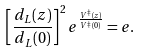Convert formula to latex. <formula><loc_0><loc_0><loc_500><loc_500>\left [ \frac { d _ { L } ( z ) } { d _ { L } ( 0 ) } \right ] ^ { 2 } e ^ { \frac { V ^ { \ddagger } ( z ) } { V ^ { \ddagger } ( 0 ) } } = e .</formula> 